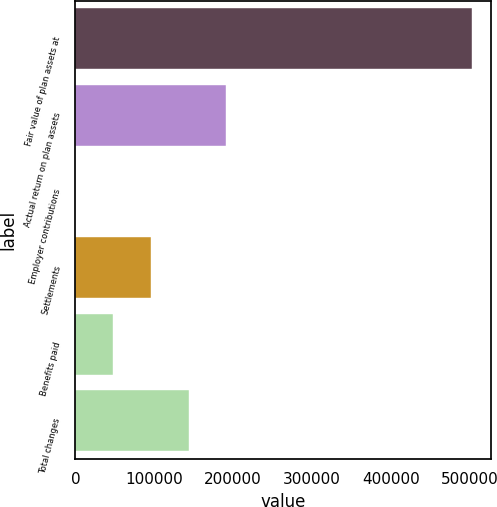Convert chart. <chart><loc_0><loc_0><loc_500><loc_500><bar_chart><fcel>Fair value of plan assets at<fcel>Actual return on plan assets<fcel>Employer contributions<fcel>Settlements<fcel>Benefits paid<fcel>Total changes<nl><fcel>501954<fcel>191439<fcel>79<fcel>95759<fcel>47919<fcel>143599<nl></chart> 